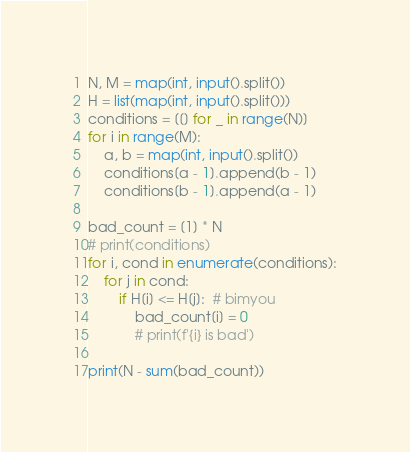<code> <loc_0><loc_0><loc_500><loc_500><_Python_>N, M = map(int, input().split())
H = list(map(int, input().split()))
conditions = [[] for _ in range(N)]
for i in range(M):
    a, b = map(int, input().split())
    conditions[a - 1].append(b - 1)
    conditions[b - 1].append(a - 1)

bad_count = [1] * N
# print(conditions)
for i, cond in enumerate(conditions):
    for j in cond:
        if H[i] <= H[j]:  # bimyou
            bad_count[i] = 0
            # print(f'{i} is bad')

print(N - sum(bad_count))
</code> 